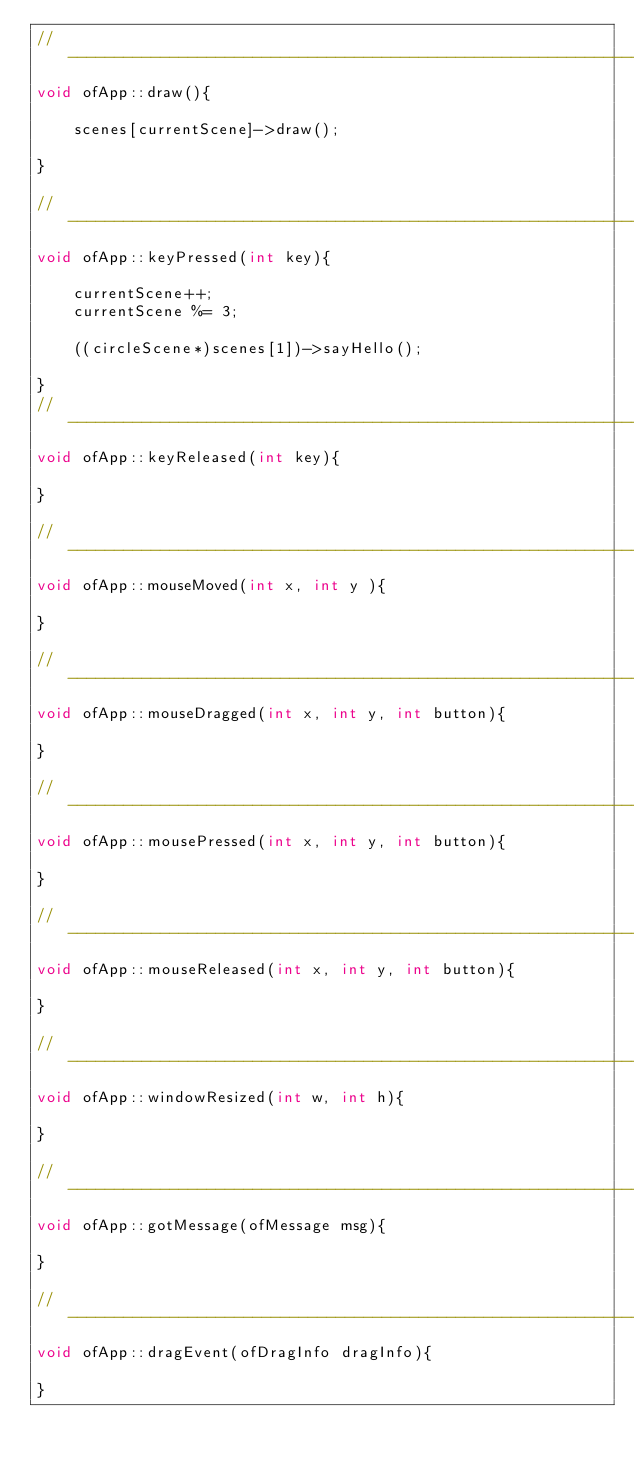Convert code to text. <code><loc_0><loc_0><loc_500><loc_500><_C++_>//--------------------------------------------------------------
void ofApp::draw(){
	
	scenes[currentScene]->draw();
	
}

//--------------------------------------------------------------
void ofApp::keyPressed(int key){
	
	currentScene++;
	currentScene %= 3;
	
	((circleScene*)scenes[1])->sayHello();
	
}
//--------------------------------------------------------------
void ofApp::keyReleased(int key){

}

//--------------------------------------------------------------
void ofApp::mouseMoved(int x, int y ){

}

//--------------------------------------------------------------
void ofApp::mouseDragged(int x, int y, int button){

}

//--------------------------------------------------------------
void ofApp::mousePressed(int x, int y, int button){

}

//--------------------------------------------------------------
void ofApp::mouseReleased(int x, int y, int button){

}

//--------------------------------------------------------------
void ofApp::windowResized(int w, int h){

}

//--------------------------------------------------------------
void ofApp::gotMessage(ofMessage msg){

}

//--------------------------------------------------------------
void ofApp::dragEvent(ofDragInfo dragInfo){ 

}
</code> 